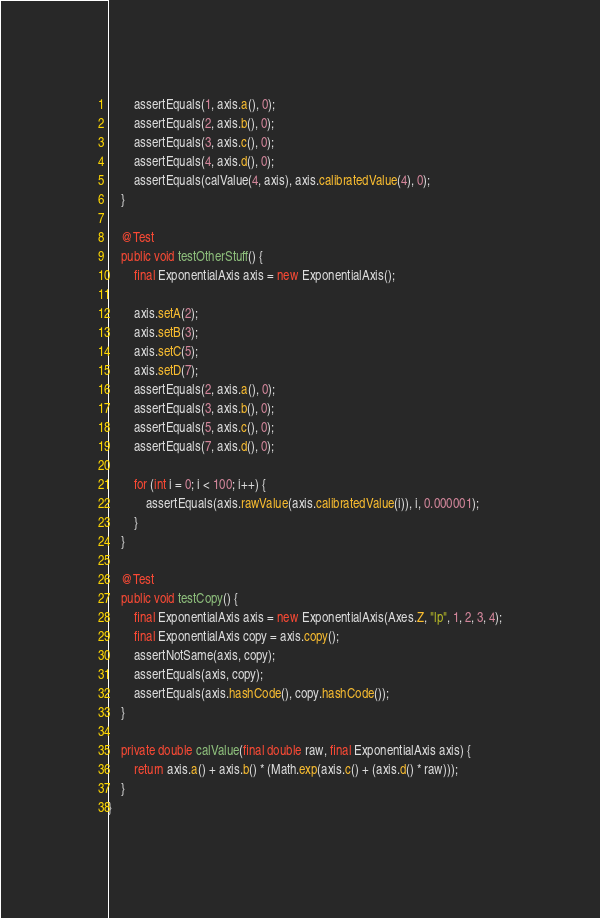<code> <loc_0><loc_0><loc_500><loc_500><_Java_>		assertEquals(1, axis.a(), 0);
		assertEquals(2, axis.b(), 0);
		assertEquals(3, axis.c(), 0);
		assertEquals(4, axis.d(), 0);
		assertEquals(calValue(4, axis), axis.calibratedValue(4), 0);
	}

	@Test
	public void testOtherStuff() {
		final ExponentialAxis axis = new ExponentialAxis();

		axis.setA(2);
		axis.setB(3);
		axis.setC(5);
		axis.setD(7);
		assertEquals(2, axis.a(), 0);
		assertEquals(3, axis.b(), 0);
		assertEquals(5, axis.c(), 0);
		assertEquals(7, axis.d(), 0);

		for (int i = 0; i < 100; i++) {
			assertEquals(axis.rawValue(axis.calibratedValue(i)), i, 0.000001);
		}
	}

	@Test
	public void testCopy() {
		final ExponentialAxis axis = new ExponentialAxis(Axes.Z, "lp", 1, 2, 3, 4);
		final ExponentialAxis copy = axis.copy();
		assertNotSame(axis, copy);
		assertEquals(axis, copy);
		assertEquals(axis.hashCode(), copy.hashCode());
	}

	private double calValue(final double raw, final ExponentialAxis axis) {
		return axis.a() + axis.b() * (Math.exp(axis.c() + (axis.d() * raw)));
	}
}
</code> 